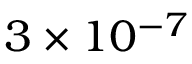<formula> <loc_0><loc_0><loc_500><loc_500>3 \times 1 0 ^ { - 7 }</formula> 